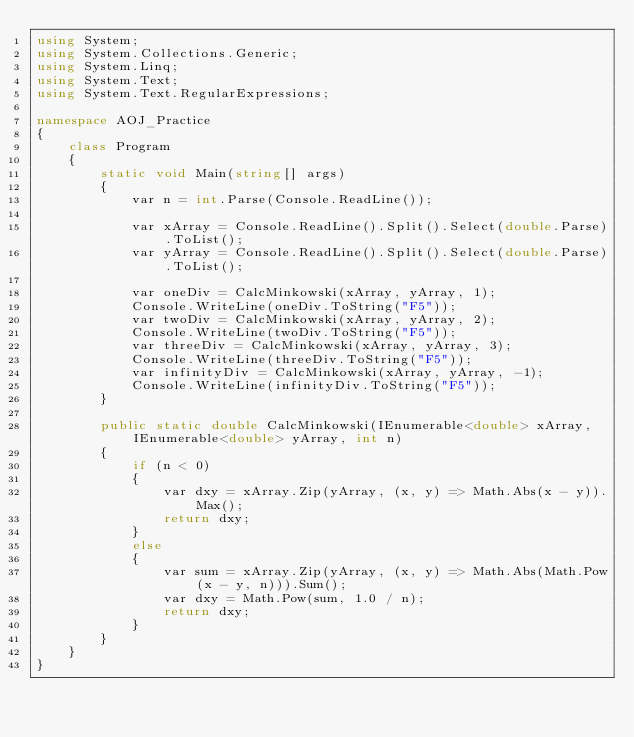<code> <loc_0><loc_0><loc_500><loc_500><_C#_>using System;
using System.Collections.Generic;
using System.Linq;
using System.Text;
using System.Text.RegularExpressions;

namespace AOJ_Practice
{
    class Program
    {
        static void Main(string[] args)
        {
            var n = int.Parse(Console.ReadLine());

            var xArray = Console.ReadLine().Split().Select(double.Parse).ToList();
            var yArray = Console.ReadLine().Split().Select(double.Parse).ToList();

            var oneDiv = CalcMinkowski(xArray, yArray, 1);
            Console.WriteLine(oneDiv.ToString("F5"));
            var twoDiv = CalcMinkowski(xArray, yArray, 2);
            Console.WriteLine(twoDiv.ToString("F5"));
            var threeDiv = CalcMinkowski(xArray, yArray, 3);
            Console.WriteLine(threeDiv.ToString("F5"));
            var infinityDiv = CalcMinkowski(xArray, yArray, -1);
            Console.WriteLine(infinityDiv.ToString("F5"));
        }

        public static double CalcMinkowski(IEnumerable<double> xArray, IEnumerable<double> yArray, int n)
        {
            if (n < 0)
            {
                var dxy = xArray.Zip(yArray, (x, y) => Math.Abs(x - y)).Max();
                return dxy;
            }
            else
            {
                var sum = xArray.Zip(yArray, (x, y) => Math.Abs(Math.Pow(x - y, n))).Sum();
                var dxy = Math.Pow(sum, 1.0 / n);
                return dxy;
            }
        }
    }
}

</code> 